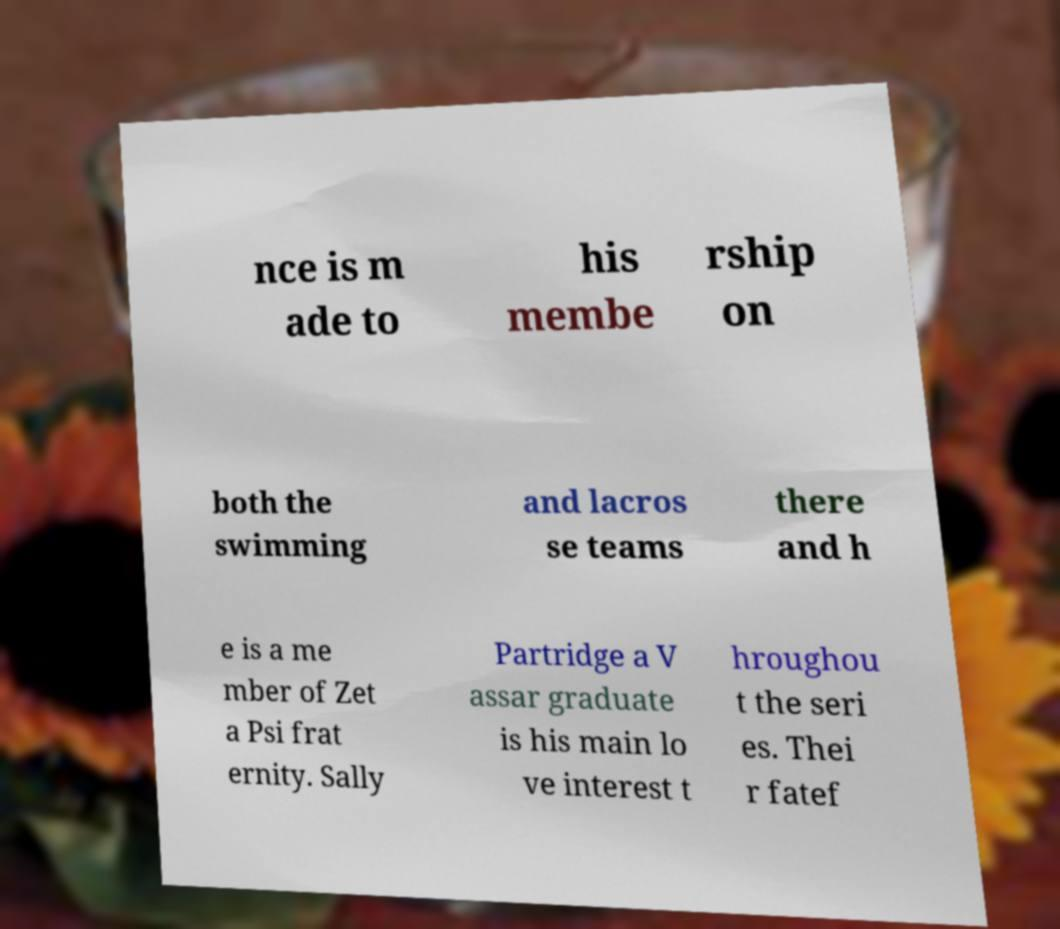Please read and relay the text visible in this image. What does it say? nce is m ade to his membe rship on both the swimming and lacros se teams there and h e is a me mber of Zet a Psi frat ernity. Sally Partridge a V assar graduate is his main lo ve interest t hroughou t the seri es. Thei r fatef 